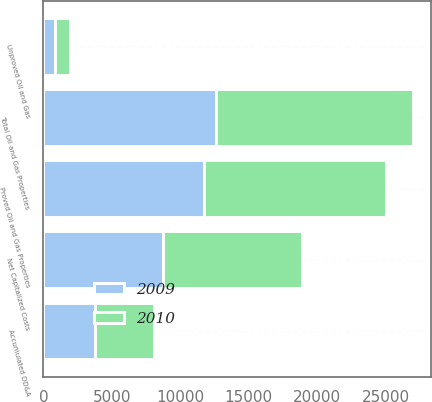Convert chart to OTSL. <chart><loc_0><loc_0><loc_500><loc_500><stacked_bar_chart><ecel><fcel>Unproved Oil and Gas<fcel>Proved Oil and Gas Properties<fcel>Total Oil and Gas Properties<fcel>Accumulated DD&A<fcel>Net Capitalized Costs<nl><fcel>2010<fcel>1081<fcel>13312<fcel>14393<fcel>4270<fcel>10123<nl><fcel>2009<fcel>874<fcel>11710<fcel>12584<fcel>3809<fcel>8775<nl></chart> 